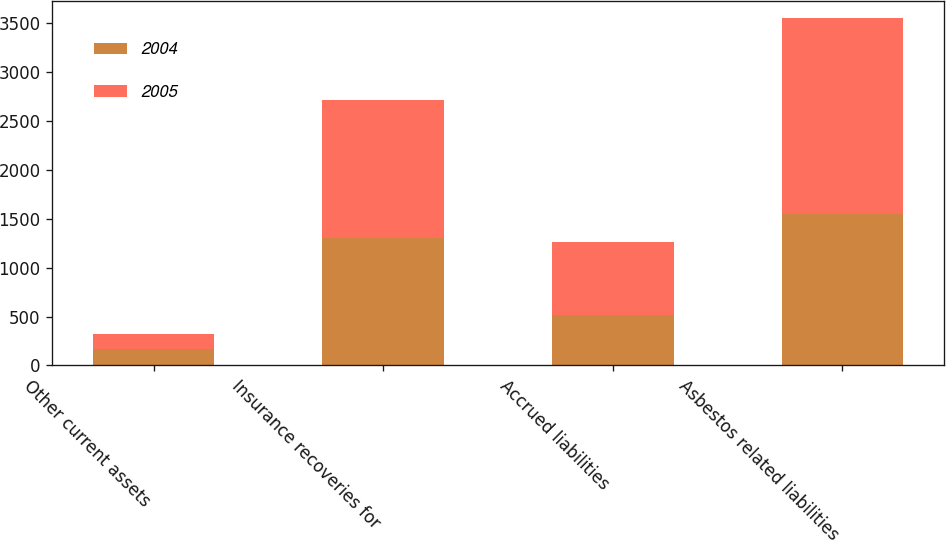Convert chart. <chart><loc_0><loc_0><loc_500><loc_500><stacked_bar_chart><ecel><fcel>Other current assets<fcel>Insurance recoveries for<fcel>Accrued liabilities<fcel>Asbestos related liabilities<nl><fcel>2004<fcel>171<fcel>1302<fcel>520<fcel>1549<nl><fcel>2005<fcel>150<fcel>1412<fcel>744<fcel>2006<nl></chart> 